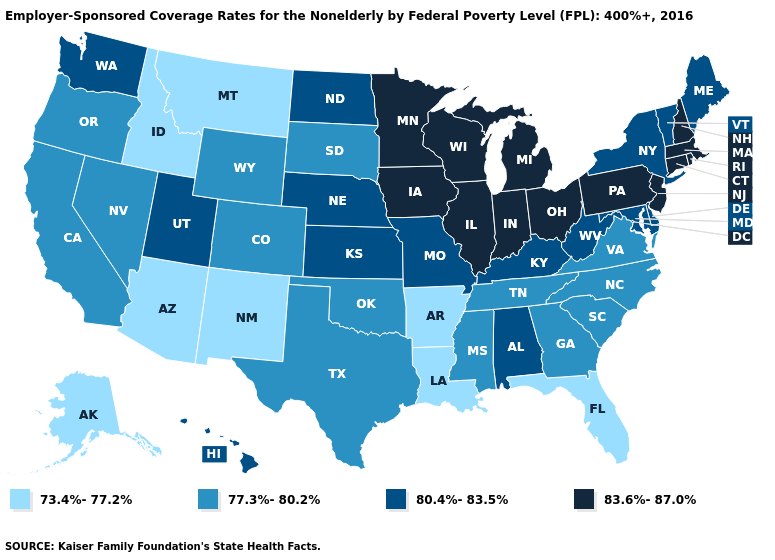What is the value of Kentucky?
Concise answer only. 80.4%-83.5%. Name the states that have a value in the range 73.4%-77.2%?
Be succinct. Alaska, Arizona, Arkansas, Florida, Idaho, Louisiana, Montana, New Mexico. What is the value of Hawaii?
Concise answer only. 80.4%-83.5%. What is the value of California?
Answer briefly. 77.3%-80.2%. Name the states that have a value in the range 83.6%-87.0%?
Quick response, please. Connecticut, Illinois, Indiana, Iowa, Massachusetts, Michigan, Minnesota, New Hampshire, New Jersey, Ohio, Pennsylvania, Rhode Island, Wisconsin. What is the lowest value in states that border Wisconsin?
Quick response, please. 83.6%-87.0%. What is the value of New Mexico?
Quick response, please. 73.4%-77.2%. Among the states that border Alabama , which have the highest value?
Write a very short answer. Georgia, Mississippi, Tennessee. Name the states that have a value in the range 80.4%-83.5%?
Write a very short answer. Alabama, Delaware, Hawaii, Kansas, Kentucky, Maine, Maryland, Missouri, Nebraska, New York, North Dakota, Utah, Vermont, Washington, West Virginia. What is the lowest value in the South?
Keep it brief. 73.4%-77.2%. What is the lowest value in states that border Arizona?
Short answer required. 73.4%-77.2%. What is the highest value in states that border Vermont?
Answer briefly. 83.6%-87.0%. What is the highest value in the USA?
Concise answer only. 83.6%-87.0%. Name the states that have a value in the range 80.4%-83.5%?
Keep it brief. Alabama, Delaware, Hawaii, Kansas, Kentucky, Maine, Maryland, Missouri, Nebraska, New York, North Dakota, Utah, Vermont, Washington, West Virginia. Which states have the highest value in the USA?
Write a very short answer. Connecticut, Illinois, Indiana, Iowa, Massachusetts, Michigan, Minnesota, New Hampshire, New Jersey, Ohio, Pennsylvania, Rhode Island, Wisconsin. 